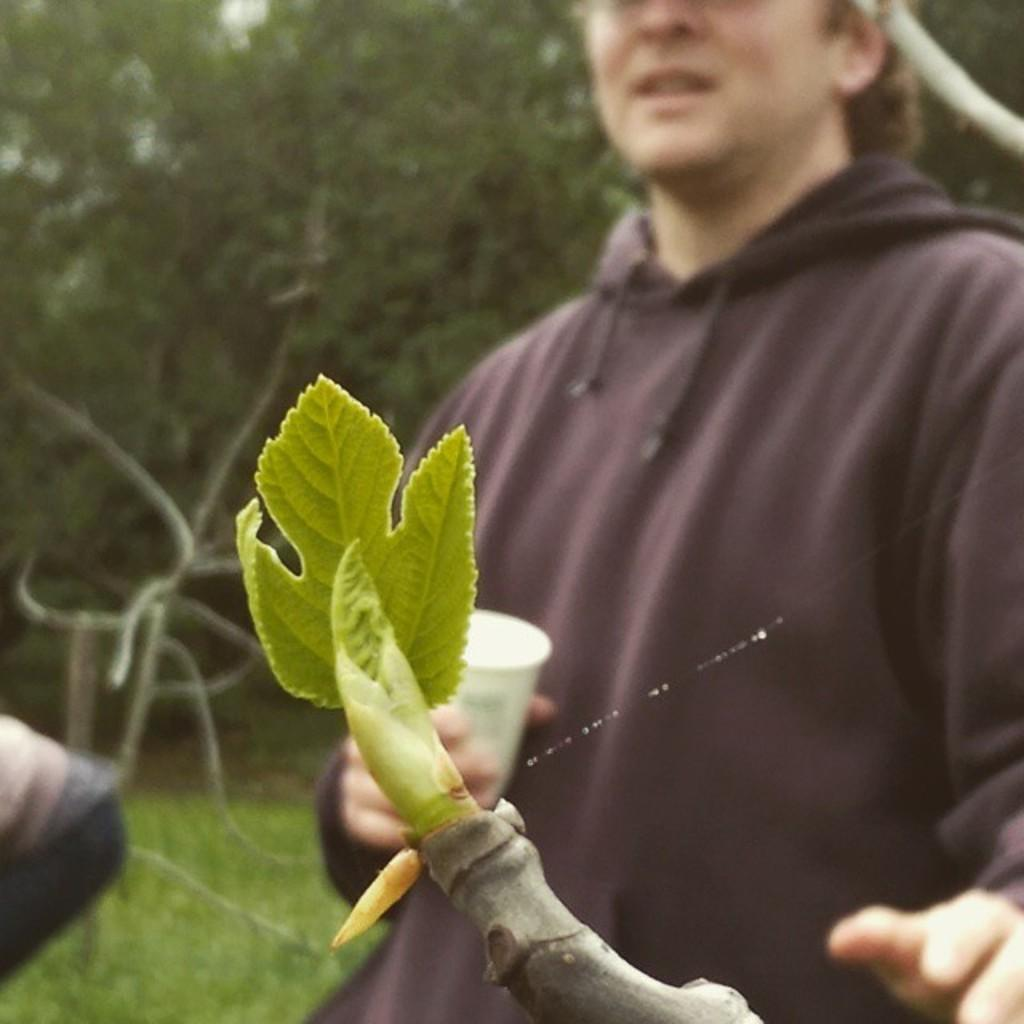How many people are present in the image? There are two people in the image. What is one person holding in the image? One person is holding a white glass. What can be seen in the background of the image? There are many trees in the background of the image. Where are the people located in the image? The people are on the ground. Where is the faucet located in the image? There is no faucet present in the image. What type of bed can be seen in the image? There is no bed present in the image. 